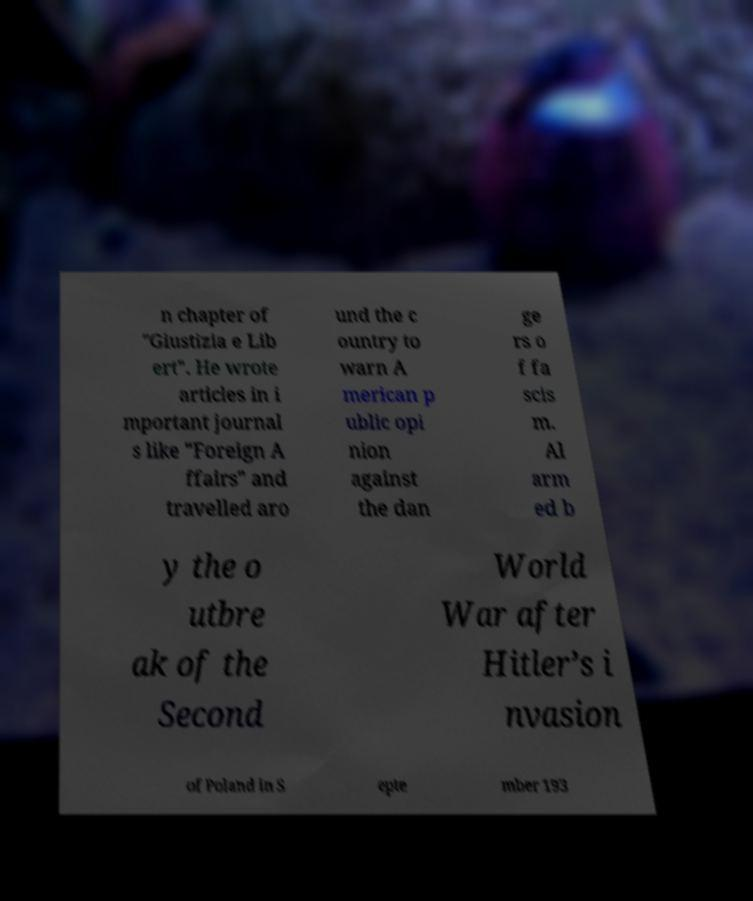Can you read and provide the text displayed in the image?This photo seems to have some interesting text. Can you extract and type it out for me? n chapter of "Giustizia e Lib ert". He wrote articles in i mportant journal s like "Foreign A ffairs" and travelled aro und the c ountry to warn A merican p ublic opi nion against the dan ge rs o f fa scis m. Al arm ed b y the o utbre ak of the Second World War after Hitler’s i nvasion of Poland in S epte mber 193 